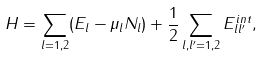Convert formula to latex. <formula><loc_0><loc_0><loc_500><loc_500>H = \sum _ { l = 1 , 2 } ( E _ { l } - \mu _ { l } N _ { l } ) + \frac { 1 } { 2 } \sum _ { l , l ^ { \prime } = 1 , 2 } E _ { l l ^ { \prime } } ^ { i n t } ,</formula> 